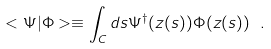<formula> <loc_0><loc_0><loc_500><loc_500>< \Psi | \Phi > \equiv \int _ { C } d s \Psi ^ { \dagger } ( z ( s ) ) \Phi ( z ( s ) ) \ .</formula> 